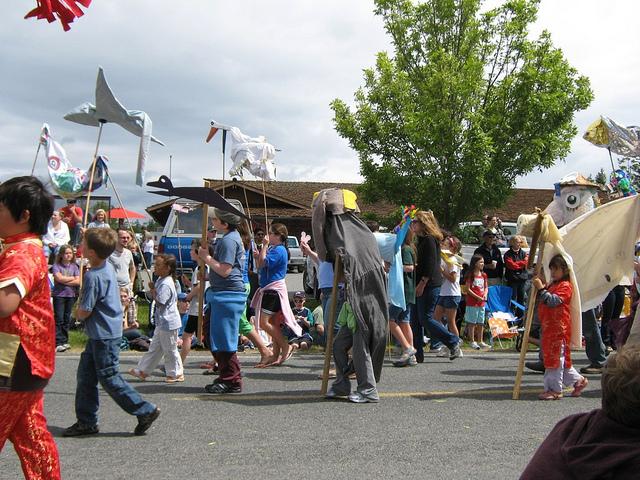How many trees are in this scene?
Keep it brief. 1. The people are having a what?
Write a very short answer. Parade. What are these people holding?
Keep it brief. Flags. What is keeping these things in the air?
Be succinct. Poles. Is this a riot?
Concise answer only. No. What is the people holding in their hands?
Short answer required. Poles. What does the man in red have over his face?
Write a very short answer. Mask. What color are the pants on the man with the red shirt?
Be succinct. Red. How many people are there?
Give a very brief answer. 20. How would describe the pattern on those kids?
Write a very short answer. Plain. Is it raining here?
Answer briefly. No. What are the building made of?
Be succinct. Wood. Is this the fair?
Concise answer only. Yes. Do these people seem to be waiting for something?
Short answer required. No. Is it dark enough for the street lights to be on?
Be succinct. No. Is the person in the red shirt carrying a flag?
Concise answer only. No. Of which country are these costumes representative?
Quick response, please. China. Are the people in the background in focus?
Answer briefly. Yes. Are all of these people in traditional indigenous dress?
Answer briefly. No. What animal does the kite look like?
Short answer required. Bird. How many people can we see standing?
Answer briefly. 18. Can you see umbrella?
Answer briefly. No. 